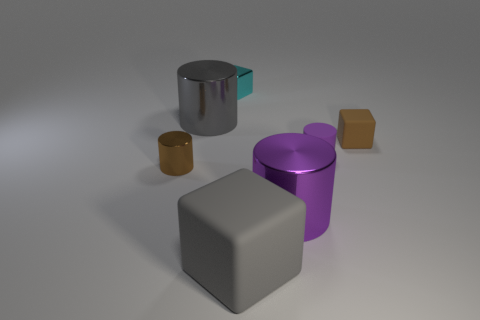Are there an equal number of brown rubber things that are on the right side of the small purple rubber cylinder and large purple cylinders?
Offer a very short reply. Yes. What is the size of the metallic object that is in front of the tiny cyan metallic thing and behind the small brown rubber cube?
Give a very brief answer. Large. The tiny metallic object in front of the gray object on the left side of the tiny cyan shiny object is what color?
Offer a terse response. Brown. How many cyan things are rubber cubes or tiny shiny cubes?
Offer a very short reply. 1. What color is the cube that is in front of the large gray cylinder and to the left of the brown block?
Make the answer very short. Gray. What number of large things are either purple matte cylinders or cyan matte blocks?
Your answer should be compact. 0. What size is the purple shiny object that is the same shape as the big gray metal thing?
Offer a very short reply. Large. The tiny cyan shiny thing is what shape?
Ensure brevity in your answer.  Cube. Do the big gray cylinder and the tiny cylinder left of the tiny shiny cube have the same material?
Ensure brevity in your answer.  Yes. What number of matte objects are gray cylinders or large purple cylinders?
Give a very brief answer. 0. 